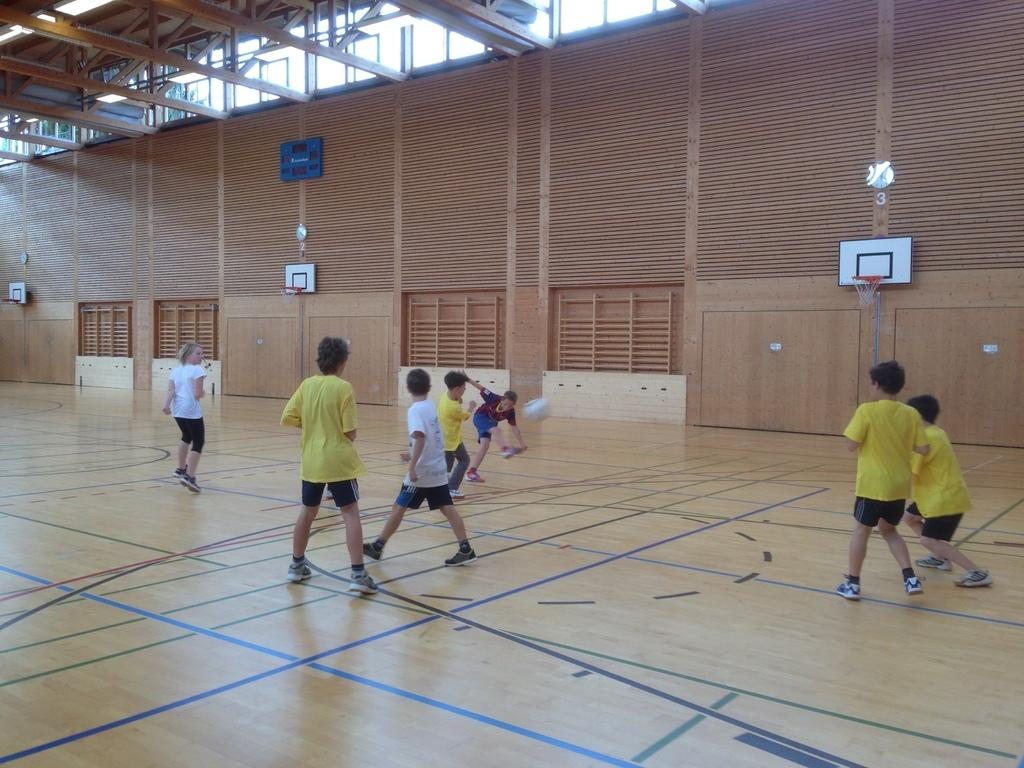What are the children in the image doing? The children are playing with a ball in the image. What can be seen in the background of the image? There is a wooden wall in the background, with basketball nets on the wall. What are the wooden rods at the top of the wall used for? The wooden rods at the top of the wall are likely used for hanging or supporting something. What type of windows are present at the top of the wall? The windows at the top of the wall are wooden. What type of steel box can be seen in the image? There is no steel box present in the image. 